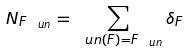Convert formula to latex. <formula><loc_0><loc_0><loc_500><loc_500>N _ { F _ { \ u n } } = \sum _ { \ u n ( F ) = F _ { \ u n } } \delta _ { F }</formula> 